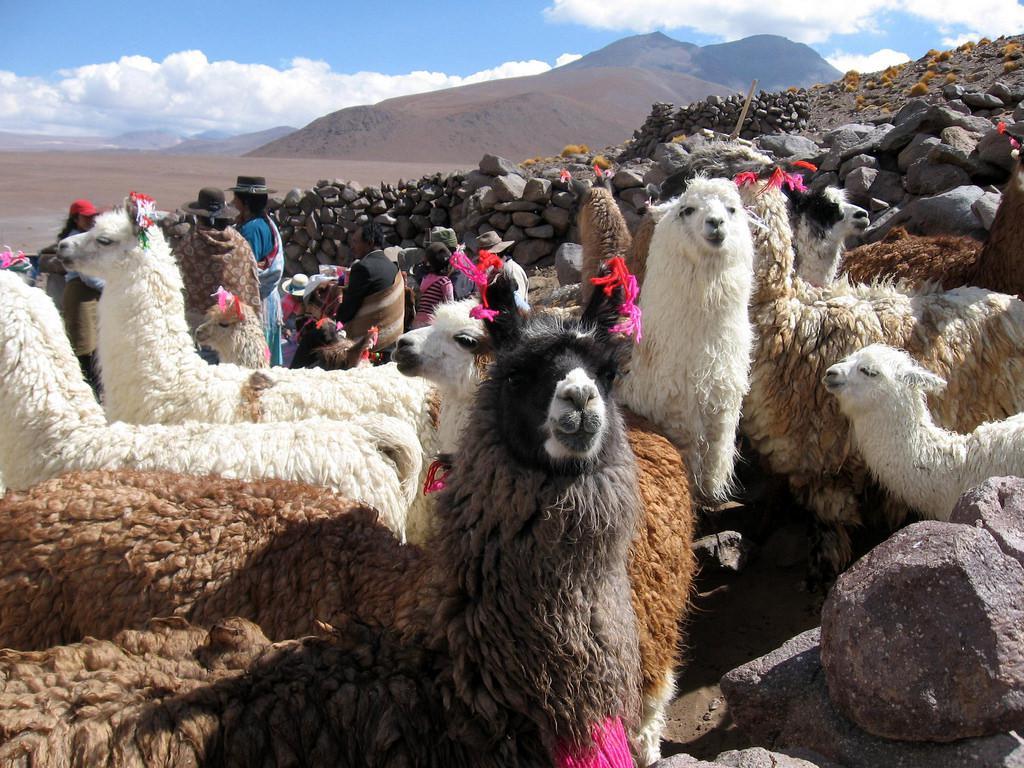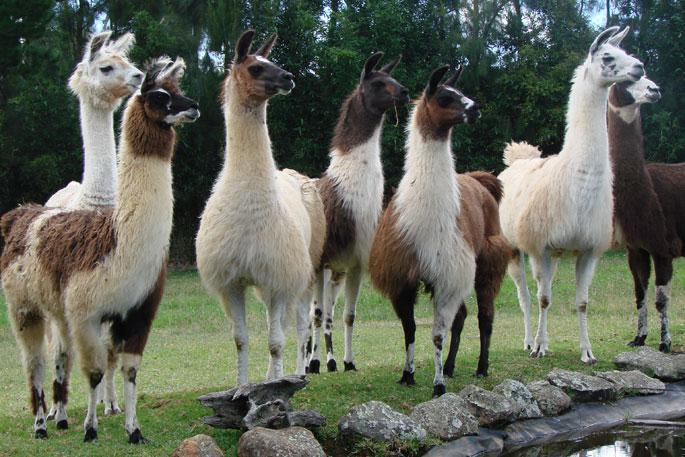The first image is the image on the left, the second image is the image on the right. Evaluate the accuracy of this statement regarding the images: "The foreground of the right image shows only camera-gazing llamas with solid colored fur.". Is it true? Answer yes or no. No. The first image is the image on the left, the second image is the image on the right. For the images displayed, is the sentence "There are at least two alpacas one fully white and the other light brown facing and looking straight forward ." factually correct? Answer yes or no. No. 